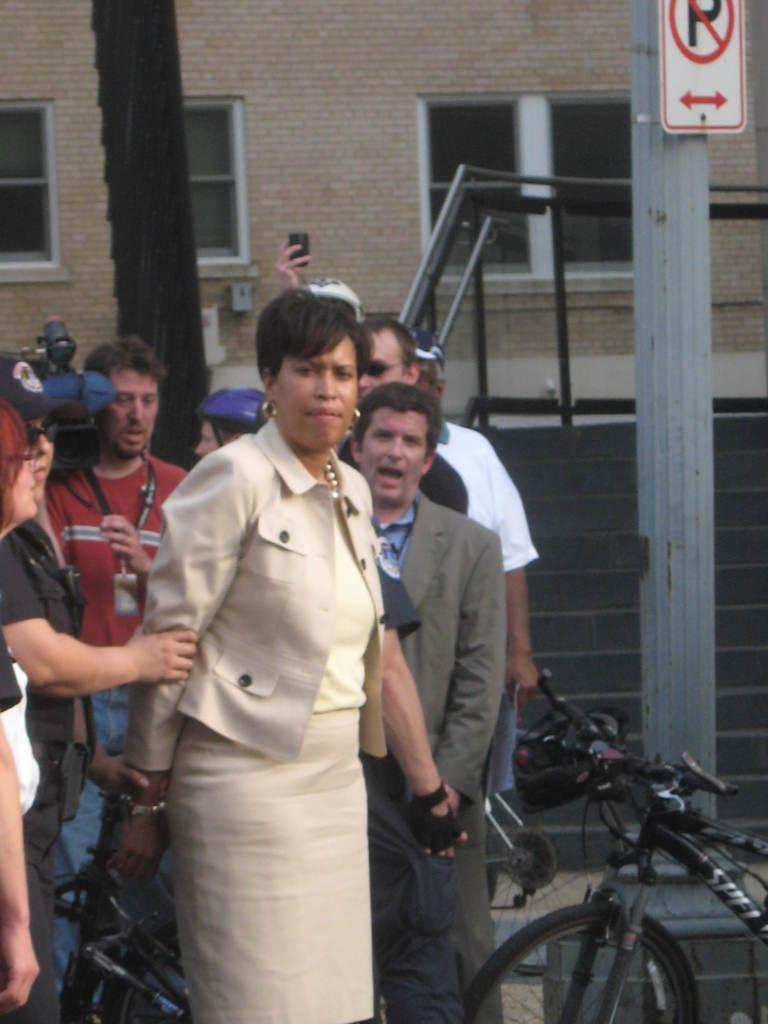What can be seen on the left side of the image? There are people on the left side of the image. What is located on the right side of the image? There is a bicycle and a pillar on the right side of the image. What is visible in the background of the image? There is a building with windows in the background of the image. How many dimes are scattered on the ground in the image? There are no dimes present in the image. What type of wool is being used to create the pillar on the right side of the image? The pillar in the image is not made of wool; it is a solid structure. 